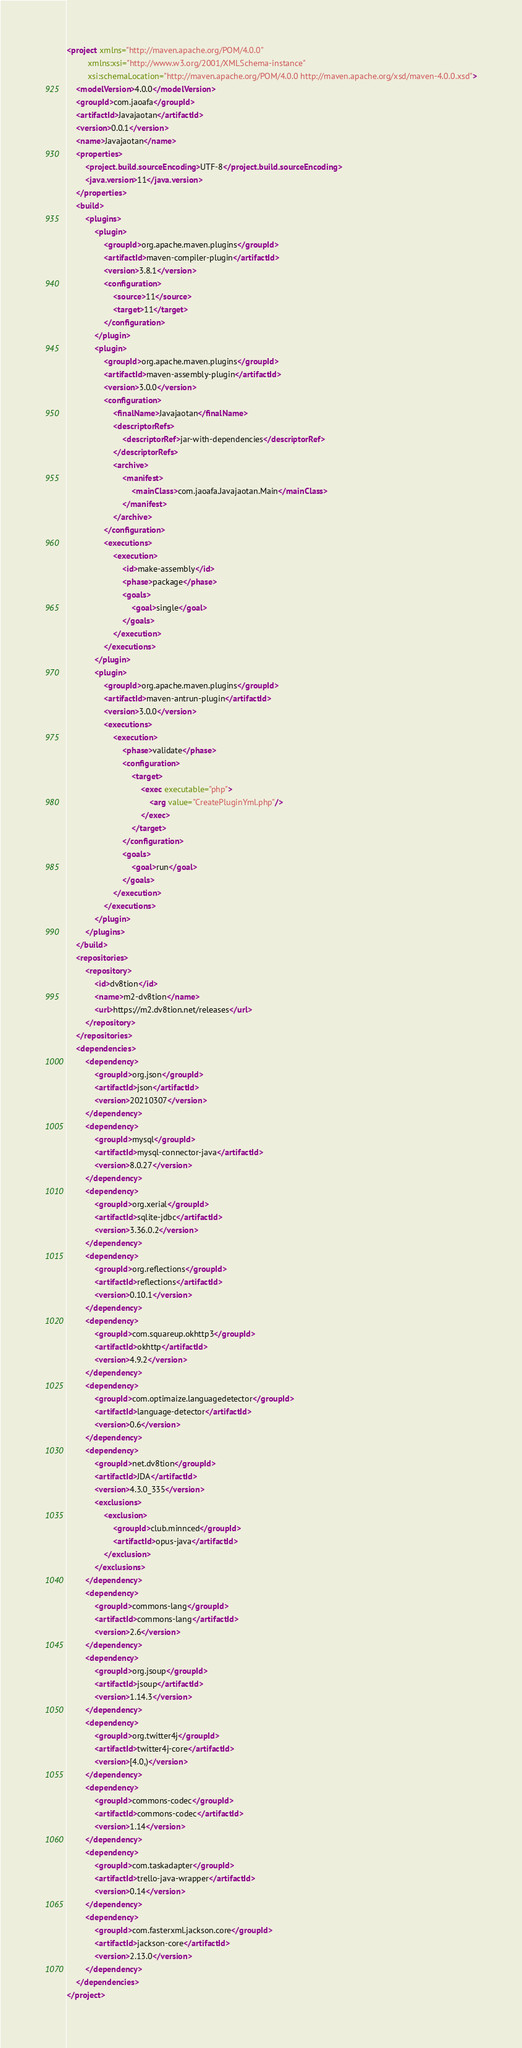<code> <loc_0><loc_0><loc_500><loc_500><_XML_><project xmlns="http://maven.apache.org/POM/4.0.0"
         xmlns:xsi="http://www.w3.org/2001/XMLSchema-instance"
         xsi:schemaLocation="http://maven.apache.org/POM/4.0.0 http://maven.apache.org/xsd/maven-4.0.0.xsd">
    <modelVersion>4.0.0</modelVersion>
    <groupId>com.jaoafa</groupId>
    <artifactId>Javajaotan</artifactId>
    <version>0.0.1</version>
    <name>Javajaotan</name>
    <properties>
        <project.build.sourceEncoding>UTF-8</project.build.sourceEncoding>
        <java.version>11</java.version>
    </properties>
    <build>
        <plugins>
            <plugin>
                <groupId>org.apache.maven.plugins</groupId>
                <artifactId>maven-compiler-plugin</artifactId>
                <version>3.8.1</version>
                <configuration>
                    <source>11</source>
                    <target>11</target>
                </configuration>
            </plugin>
            <plugin>
                <groupId>org.apache.maven.plugins</groupId>
                <artifactId>maven-assembly-plugin</artifactId>
                <version>3.0.0</version>
                <configuration>
                    <finalName>Javajaotan</finalName>
                    <descriptorRefs>
                        <descriptorRef>jar-with-dependencies</descriptorRef>
                    </descriptorRefs>
                    <archive>
                        <manifest>
                            <mainClass>com.jaoafa.Javajaotan.Main</mainClass>
                        </manifest>
                    </archive>
                </configuration>
                <executions>
                    <execution>
                        <id>make-assembly</id>
                        <phase>package</phase>
                        <goals>
                            <goal>single</goal>
                        </goals>
                    </execution>
                </executions>
            </plugin>
            <plugin>
                <groupId>org.apache.maven.plugins</groupId>
                <artifactId>maven-antrun-plugin</artifactId>
                <version>3.0.0</version>
                <executions>
                    <execution>
                        <phase>validate</phase>
                        <configuration>
                            <target>
                                <exec executable="php">
                                    <arg value="CreatePluginYml.php"/>
                                </exec>
                            </target>
                        </configuration>
                        <goals>
                            <goal>run</goal>
                        </goals>
                    </execution>
                </executions>
            </plugin>
        </plugins>
    </build>
    <repositories>
        <repository>
            <id>dv8tion</id>
            <name>m2-dv8tion</name>
            <url>https://m2.dv8tion.net/releases</url>
        </repository>
    </repositories>
    <dependencies>
        <dependency>
            <groupId>org.json</groupId>
            <artifactId>json</artifactId>
            <version>20210307</version>
        </dependency>
        <dependency>
            <groupId>mysql</groupId>
            <artifactId>mysql-connector-java</artifactId>
            <version>8.0.27</version>
        </dependency>
        <dependency>
            <groupId>org.xerial</groupId>
            <artifactId>sqlite-jdbc</artifactId>
            <version>3.36.0.2</version>
        </dependency>
        <dependency>
            <groupId>org.reflections</groupId>
            <artifactId>reflections</artifactId>
            <version>0.10.1</version>
        </dependency>
        <dependency>
            <groupId>com.squareup.okhttp3</groupId>
            <artifactId>okhttp</artifactId>
            <version>4.9.2</version>
        </dependency>
        <dependency>
            <groupId>com.optimaize.languagedetector</groupId>
            <artifactId>language-detector</artifactId>
            <version>0.6</version>
        </dependency>
        <dependency>
            <groupId>net.dv8tion</groupId>
            <artifactId>JDA</artifactId>
            <version>4.3.0_335</version>
            <exclusions>
                <exclusion>
                    <groupId>club.minnced</groupId>
                    <artifactId>opus-java</artifactId>
                </exclusion>
            </exclusions>
        </dependency>
        <dependency>
            <groupId>commons-lang</groupId>
            <artifactId>commons-lang</artifactId>
            <version>2.6</version>
        </dependency>
        <dependency>
            <groupId>org.jsoup</groupId>
            <artifactId>jsoup</artifactId>
            <version>1.14.3</version>
        </dependency>
        <dependency>
            <groupId>org.twitter4j</groupId>
            <artifactId>twitter4j-core</artifactId>
            <version>[4.0,)</version>
        </dependency>
        <dependency>
            <groupId>commons-codec</groupId>
            <artifactId>commons-codec</artifactId>
            <version>1.14</version>
        </dependency>
        <dependency>
            <groupId>com.taskadapter</groupId>
            <artifactId>trello-java-wrapper</artifactId>
            <version>0.14</version>
        </dependency>
        <dependency>
            <groupId>com.fasterxml.jackson.core</groupId>
            <artifactId>jackson-core</artifactId>
            <version>2.13.0</version>
        </dependency>
    </dependencies>
</project></code> 